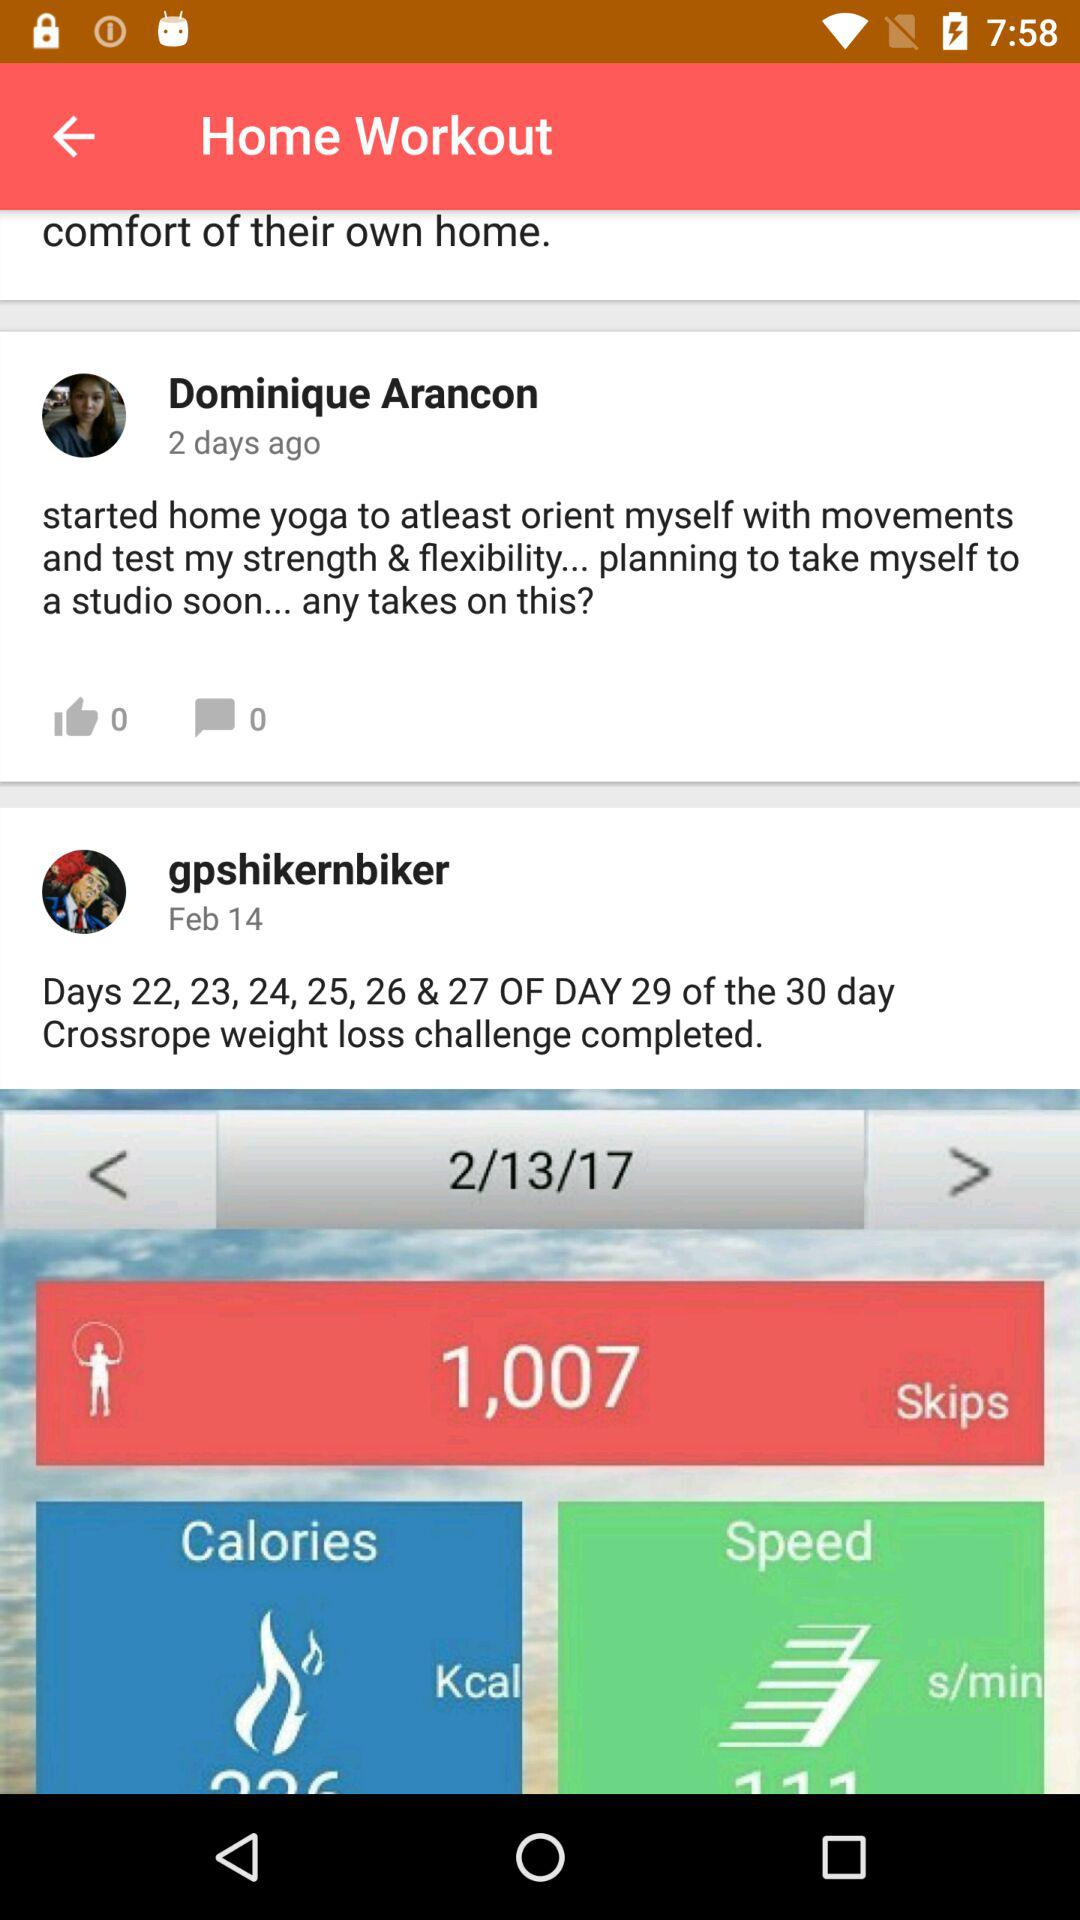When did "gpshikernbiker" post? "gpshikernbiker" posted on February 14. 